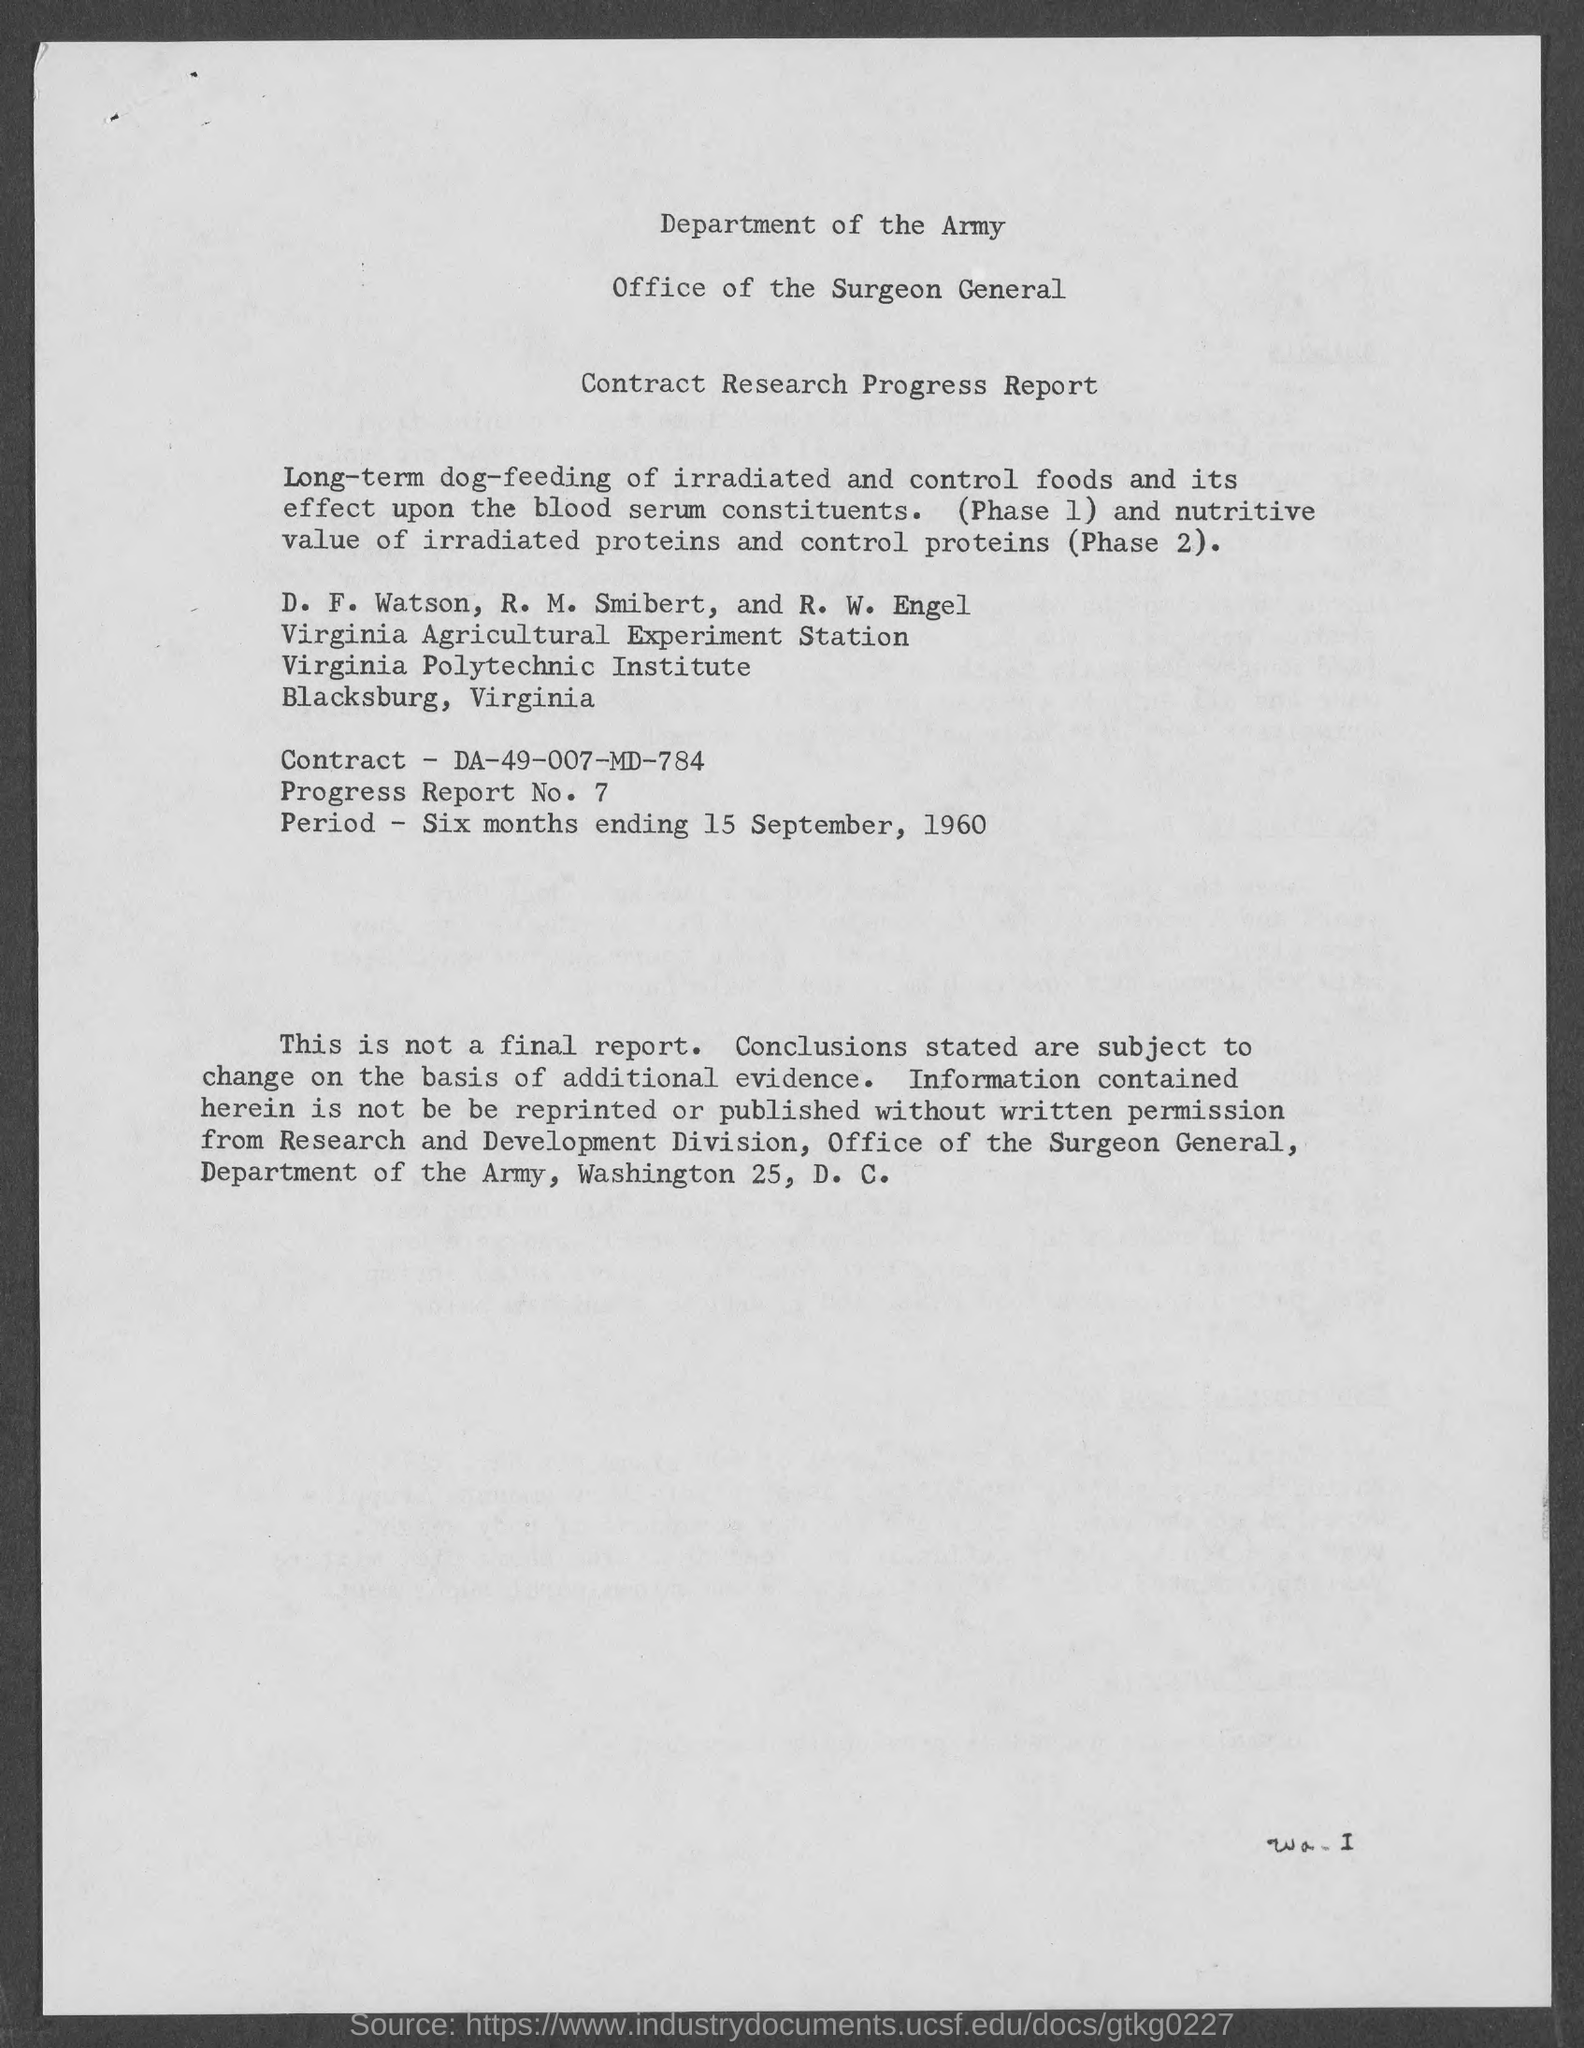What is the progress Report No. given in the document?
Offer a terse response. 7. What is the period of contract mentioned in the document?
Make the answer very short. Six months ending 15 September, 1960. What is the Contract No. given in the document?
Ensure brevity in your answer.  DA-49-007-MD-784. 